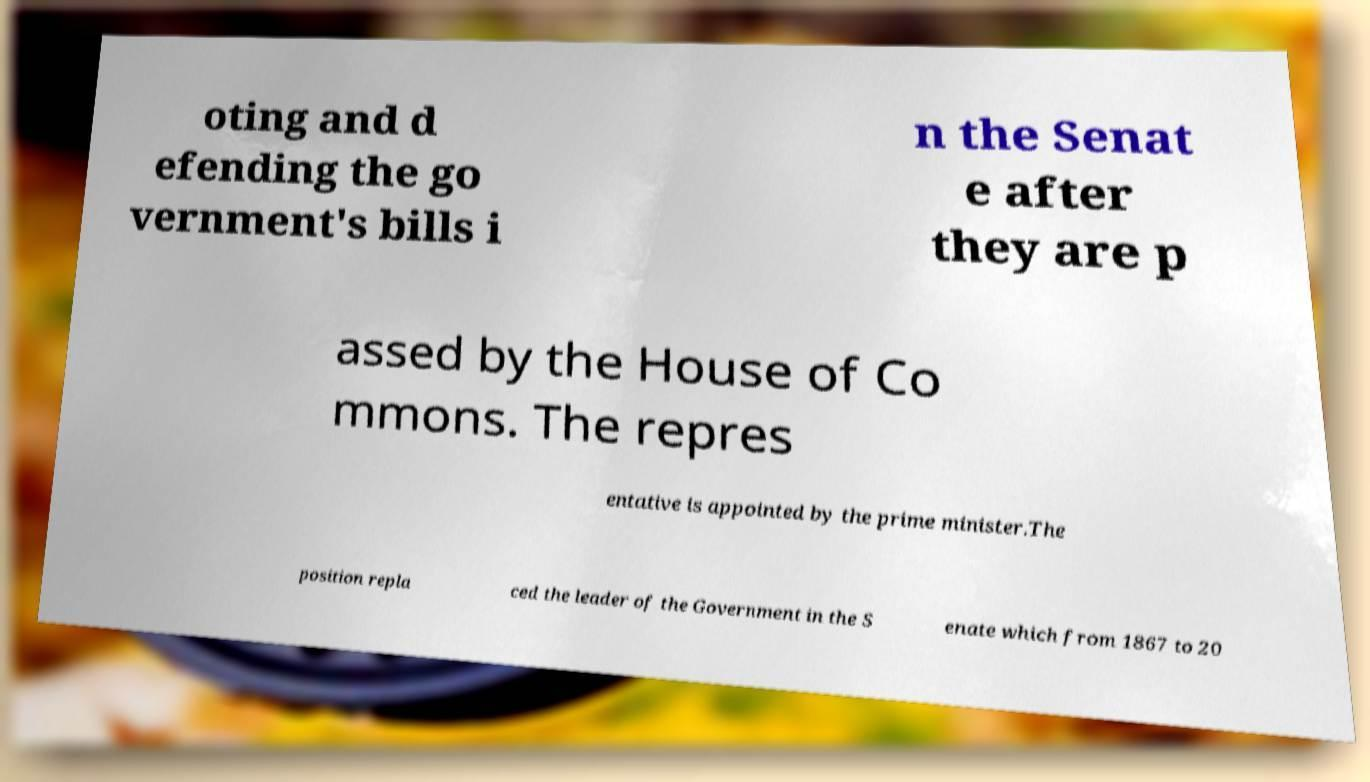What messages or text are displayed in this image? I need them in a readable, typed format. oting and d efending the go vernment's bills i n the Senat e after they are p assed by the House of Co mmons. The repres entative is appointed by the prime minister.The position repla ced the leader of the Government in the S enate which from 1867 to 20 